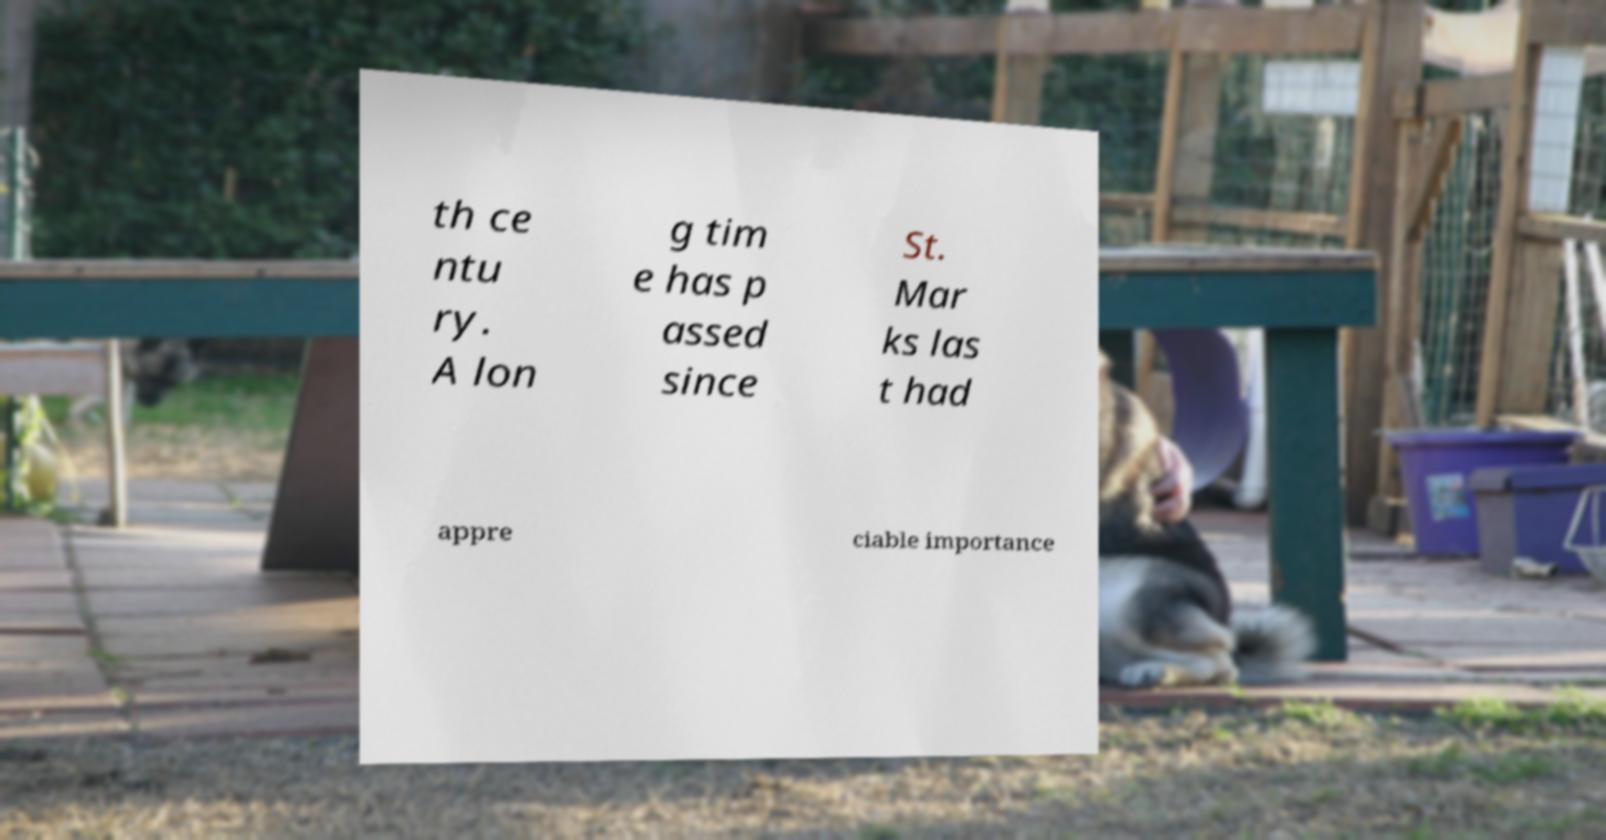Could you assist in decoding the text presented in this image and type it out clearly? th ce ntu ry. A lon g tim e has p assed since St. Mar ks las t had appre ciable importance 